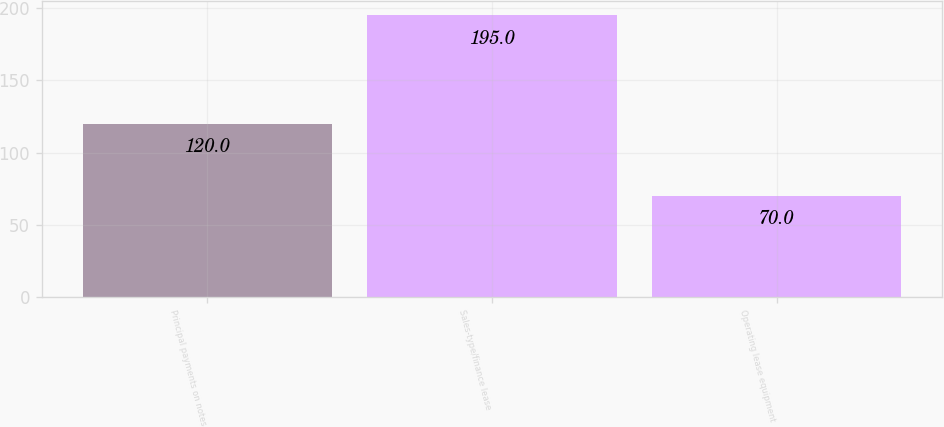<chart> <loc_0><loc_0><loc_500><loc_500><bar_chart><fcel>Principal payments on notes<fcel>Sales-type/finance lease<fcel>Operating lease equipment<nl><fcel>120<fcel>195<fcel>70<nl></chart> 